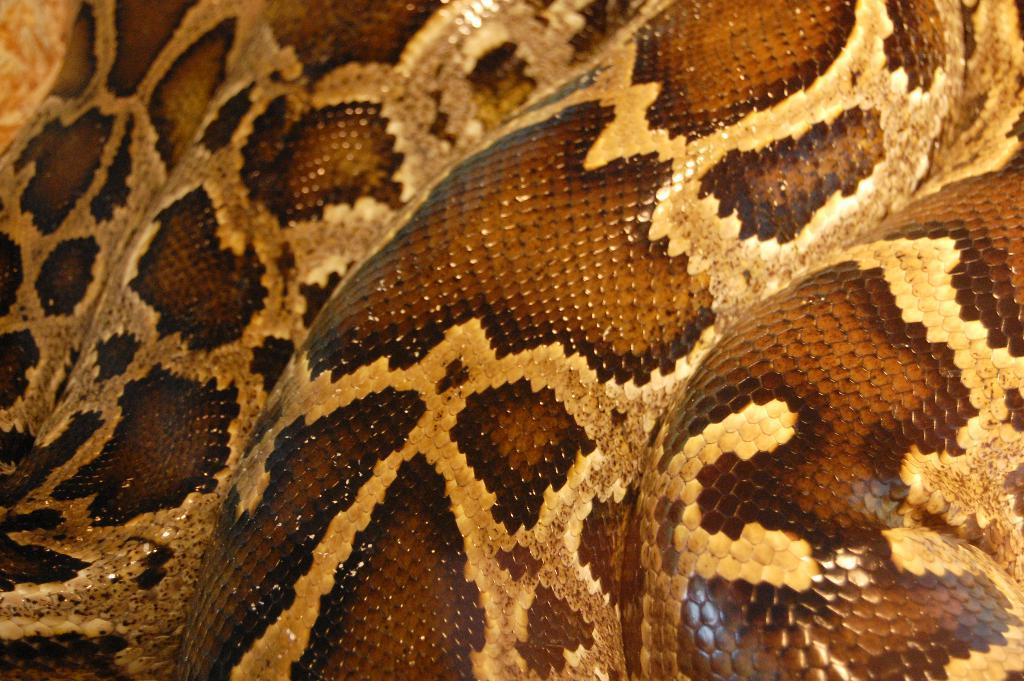What is the main subject of the image? The main subject of the image is a snake skin. Can you describe the colors of the snake skin? The snake skin has brown and cream colors. How many stars can be seen on the snake skin in the image? There are no stars present on the snake skin in the image. 